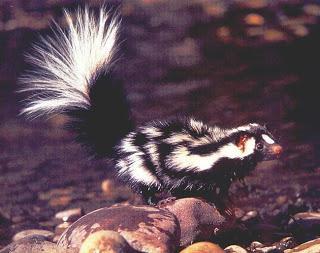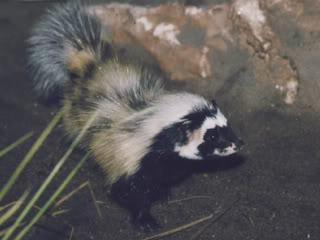The first image is the image on the left, the second image is the image on the right. For the images shown, is this caption "Both skunks are pointed in the same direction." true? Answer yes or no. Yes. 